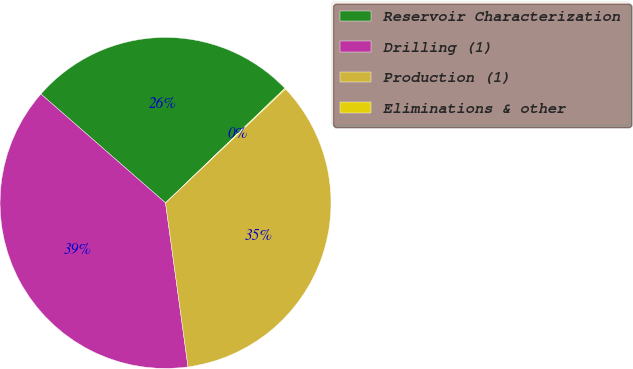<chart> <loc_0><loc_0><loc_500><loc_500><pie_chart><fcel>Reservoir Characterization<fcel>Drilling (1)<fcel>Production (1)<fcel>Eliminations & other<nl><fcel>26.39%<fcel>38.6%<fcel>34.92%<fcel>0.09%<nl></chart> 